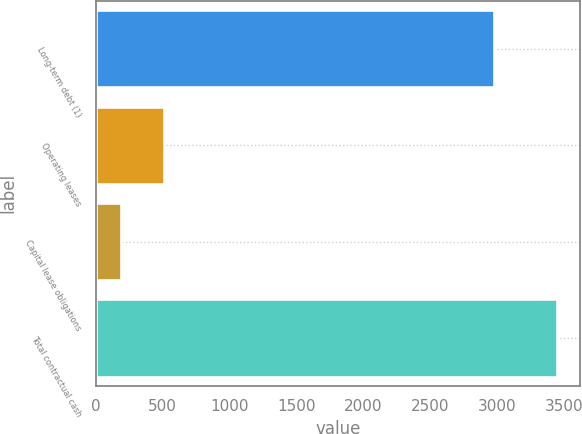Convert chart. <chart><loc_0><loc_0><loc_500><loc_500><bar_chart><fcel>Long-term debt (1)<fcel>Operating leases<fcel>Capital lease obligations<fcel>Total contractual cash<nl><fcel>2979<fcel>511.5<fcel>185<fcel>3450<nl></chart> 